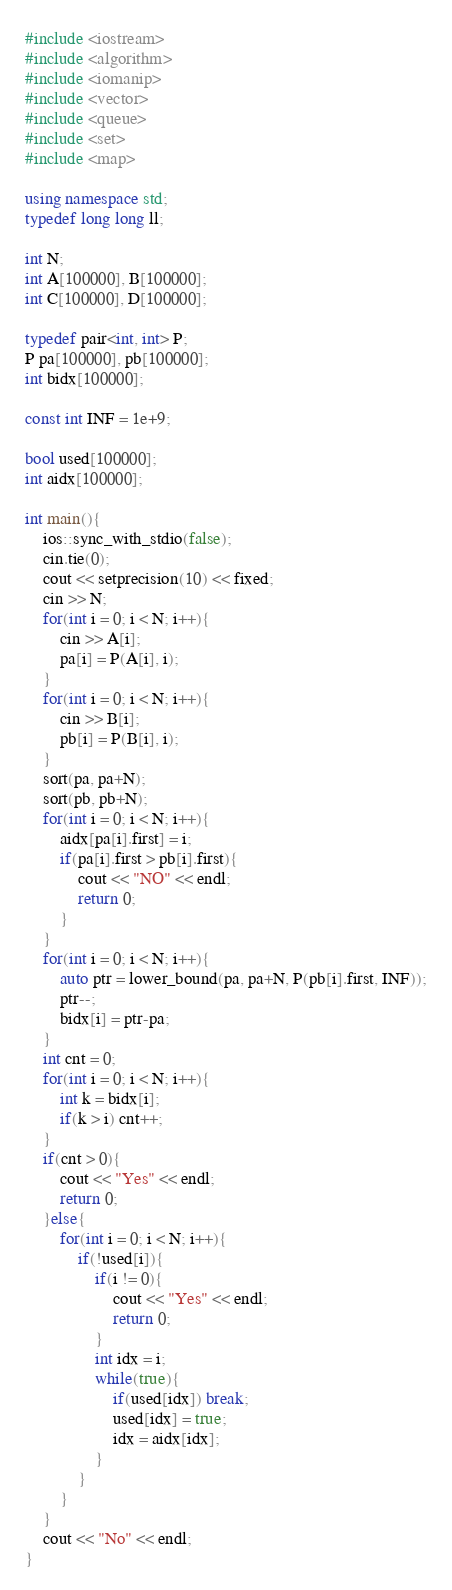<code> <loc_0><loc_0><loc_500><loc_500><_C++_>#include <iostream>
#include <algorithm>
#include <iomanip>
#include <vector>
#include <queue>
#include <set>
#include <map>

using namespace std;
typedef long long ll;

int N;
int A[100000], B[100000];
int C[100000], D[100000];

typedef pair<int, int> P;
P pa[100000], pb[100000];
int bidx[100000];

const int INF = 1e+9;

bool used[100000];
int aidx[100000];

int main(){
    ios::sync_with_stdio(false);
    cin.tie(0);
    cout << setprecision(10) << fixed;
    cin >> N;
    for(int i = 0; i < N; i++){
        cin >> A[i];
        pa[i] = P(A[i], i);
    }
    for(int i = 0; i < N; i++){
        cin >> B[i];
        pb[i] = P(B[i], i);
    }
    sort(pa, pa+N);
    sort(pb, pb+N);
    for(int i = 0; i < N; i++){
        aidx[pa[i].first] = i;
        if(pa[i].first > pb[i].first){
            cout << "NO" << endl;
            return 0;
        }
    }
    for(int i = 0; i < N; i++){
        auto ptr = lower_bound(pa, pa+N, P(pb[i].first, INF));
        ptr--;
        bidx[i] = ptr-pa;
    }
    int cnt = 0;
    for(int i = 0; i < N; i++){
        int k = bidx[i];
        if(k > i) cnt++;
    }
    if(cnt > 0){
        cout << "Yes" << endl;
        return 0;
    }else{
        for(int i = 0; i < N; i++){
            if(!used[i]){
                if(i != 0){
                    cout << "Yes" << endl;
                    return 0;
                }
                int idx = i;
                while(true){
                    if(used[idx]) break;
                    used[idx] = true;
                    idx = aidx[idx];
                }
            }
        }
    }
    cout << "No" << endl;
}</code> 